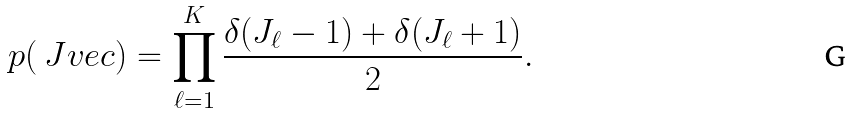Convert formula to latex. <formula><loc_0><loc_0><loc_500><loc_500>p ( \ J v e c ) = \prod _ { \ell = 1 } ^ { K } \frac { \delta ( J _ { \ell } - 1 ) + \delta ( J _ { \ell } + 1 ) } { 2 } .</formula> 